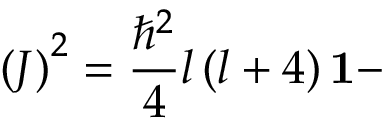Convert formula to latex. <formula><loc_0><loc_0><loc_500><loc_500>\left ( J \right ) ^ { 2 } = \frac { \hbar { ^ } { 2 } } { 4 } l \left ( l + 4 \right ) 1 -</formula> 